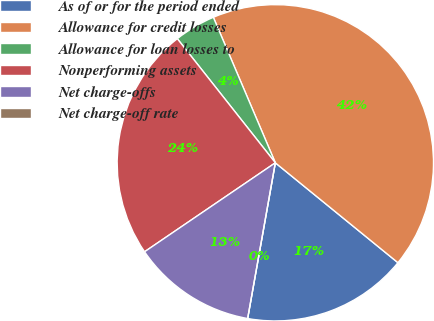<chart> <loc_0><loc_0><loc_500><loc_500><pie_chart><fcel>As of or for the period ended<fcel>Allowance for credit losses<fcel>Allowance for loan losses to<fcel>Nonperforming assets<fcel>Net charge-offs<fcel>Net charge-off rate<nl><fcel>16.92%<fcel>42.29%<fcel>4.23%<fcel>23.87%<fcel>12.69%<fcel>0.0%<nl></chart> 